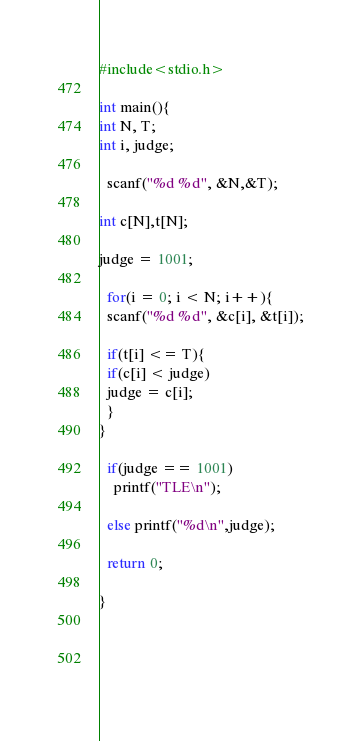Convert code to text. <code><loc_0><loc_0><loc_500><loc_500><_C++_>#include<stdio.h>
 
int main(){
int N, T;
int i, judge;

  scanf("%d %d", &N,&T);
  
int c[N],t[N];

judge = 1001;
 
  for(i = 0; i < N; i++){
  scanf("%d %d", &c[i], &t[i]);

  if(t[i] <= T){
  if(c[i] < judge)
  judge = c[i];
  }
}
 
  if(judge == 1001)
    printf("TLE\n");
 
  else printf("%d\n",judge);

  return 0;
 
}
 
  
 
  </code> 